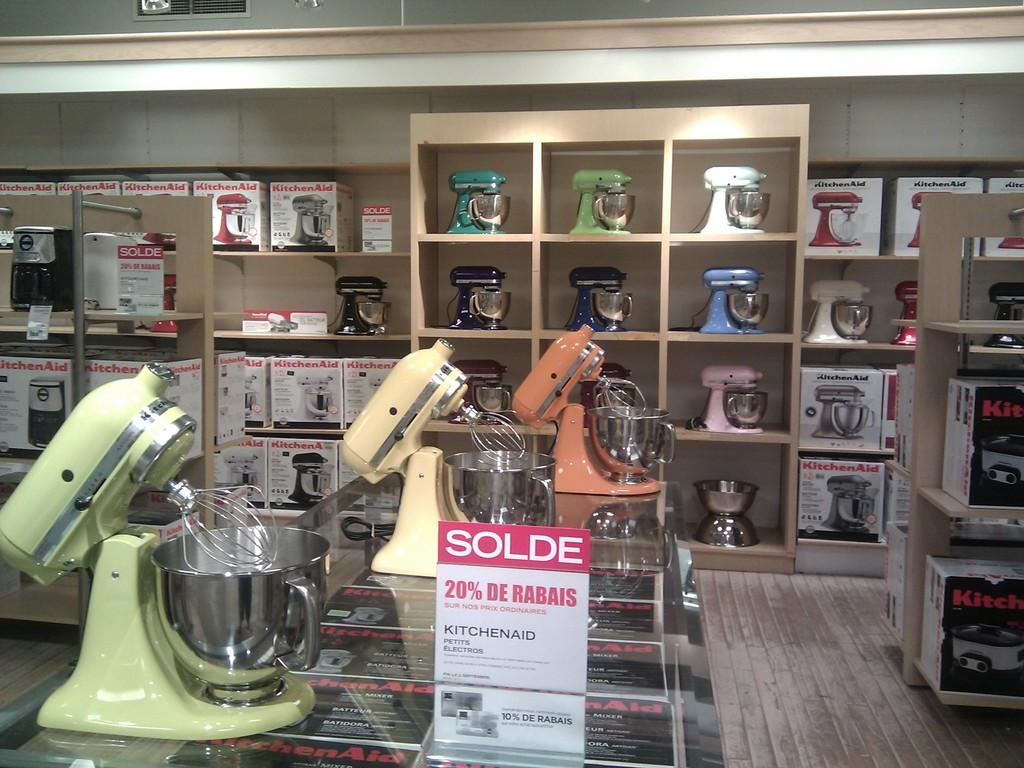What objects are on the glass surface in the image? There are blending machines on a glass surface in the image. What is the board used for in the image? The purpose of the board in the image is not specified, but it could be used for displaying information or as a work surface. What can be seen in the background of the image? In the background of the image, there are machines, boxes in racks, and a wall. What type of surface is visible beneath the glass surface? The floor is visible in the image. How many bees are flying around the blending machines in the image? There are no bees present in the image. What type of town is depicted in the background of the image? There is no town visible in the image; it is an indoor setting with machines and boxes in racks. 